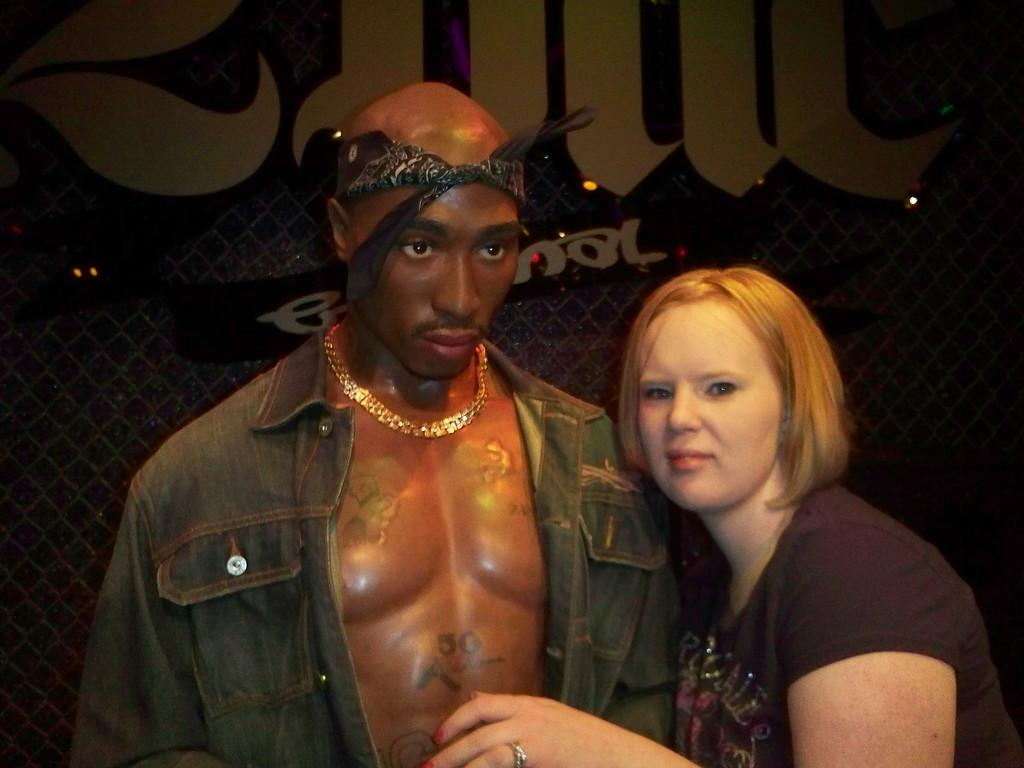How many people are in the image? There are two people standing in the center of the image. What are the people wearing? One of the men is wearing a jacket. What accessory does the man wearing a jacket have? The man wearing a jacket has a chain. What can be seen in the background of the image? There is a wall and lights visible in the background of the image. What type of food is being served in the image? There is no food visible in the image. Can you describe the view from the location in the image? The image does not provide enough information to describe the view from the location. 